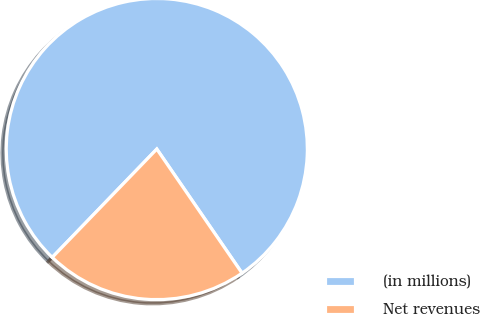Convert chart to OTSL. <chart><loc_0><loc_0><loc_500><loc_500><pie_chart><fcel>(in millions)<fcel>Net revenues<nl><fcel>78.2%<fcel>21.8%<nl></chart> 